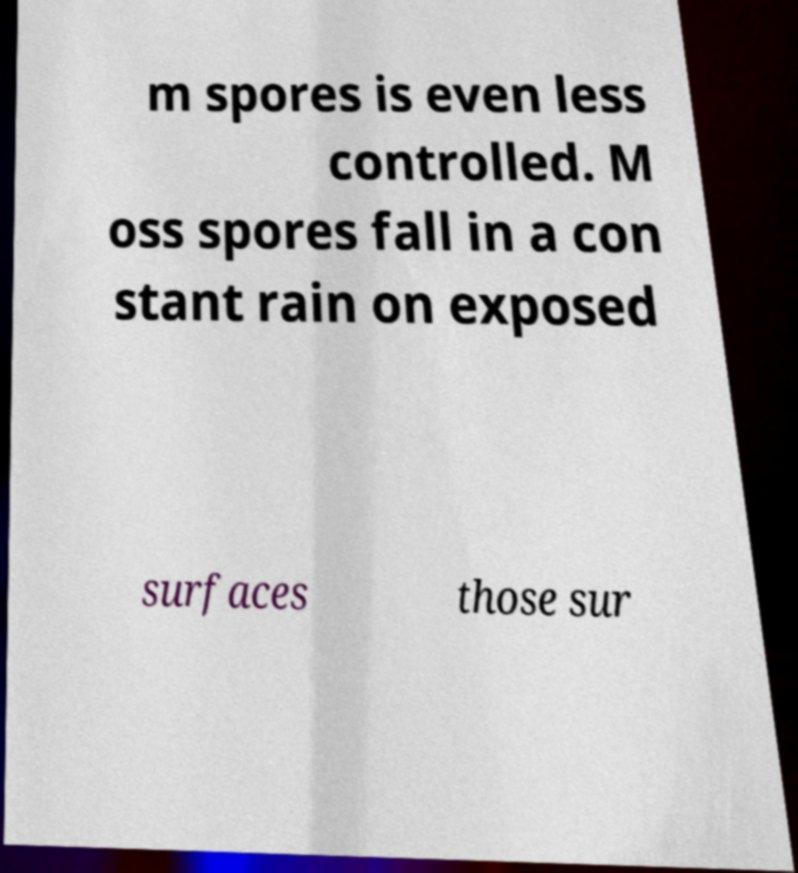What messages or text are displayed in this image? I need them in a readable, typed format. m spores is even less controlled. M oss spores fall in a con stant rain on exposed surfaces those sur 